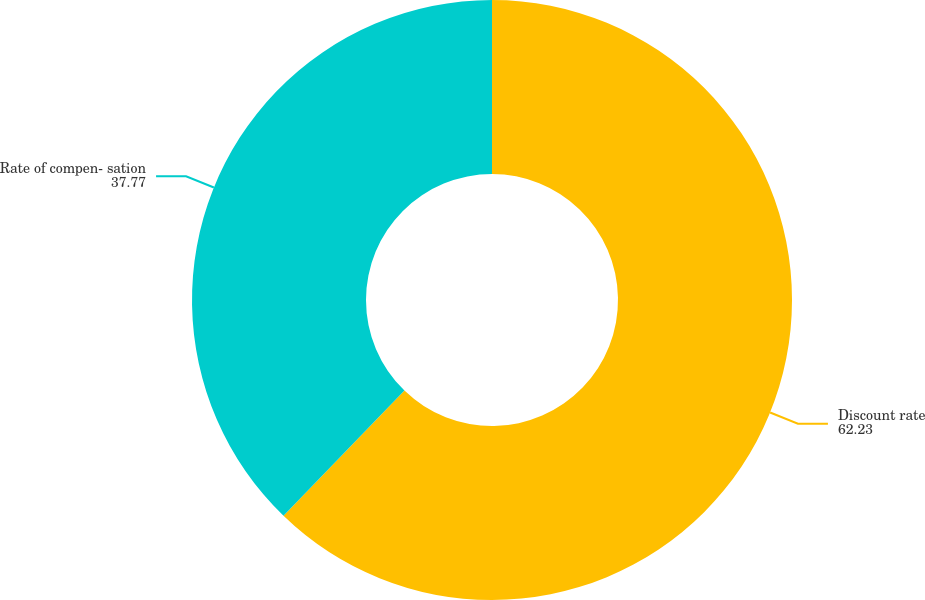Convert chart. <chart><loc_0><loc_0><loc_500><loc_500><pie_chart><fcel>Discount rate<fcel>Rate of compen- sation<nl><fcel>62.23%<fcel>37.77%<nl></chart> 